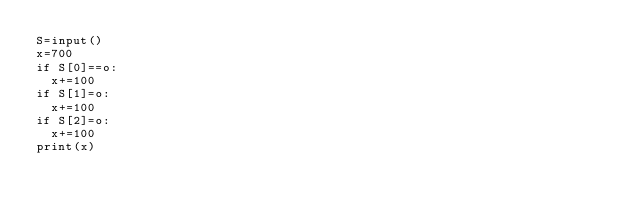<code> <loc_0><loc_0><loc_500><loc_500><_Python_>S=input()
x=700
if S[0]==o:
  x+=100
if S[1]=o:
  x+=100
if S[2]=o:
  x+=100
print(x)</code> 